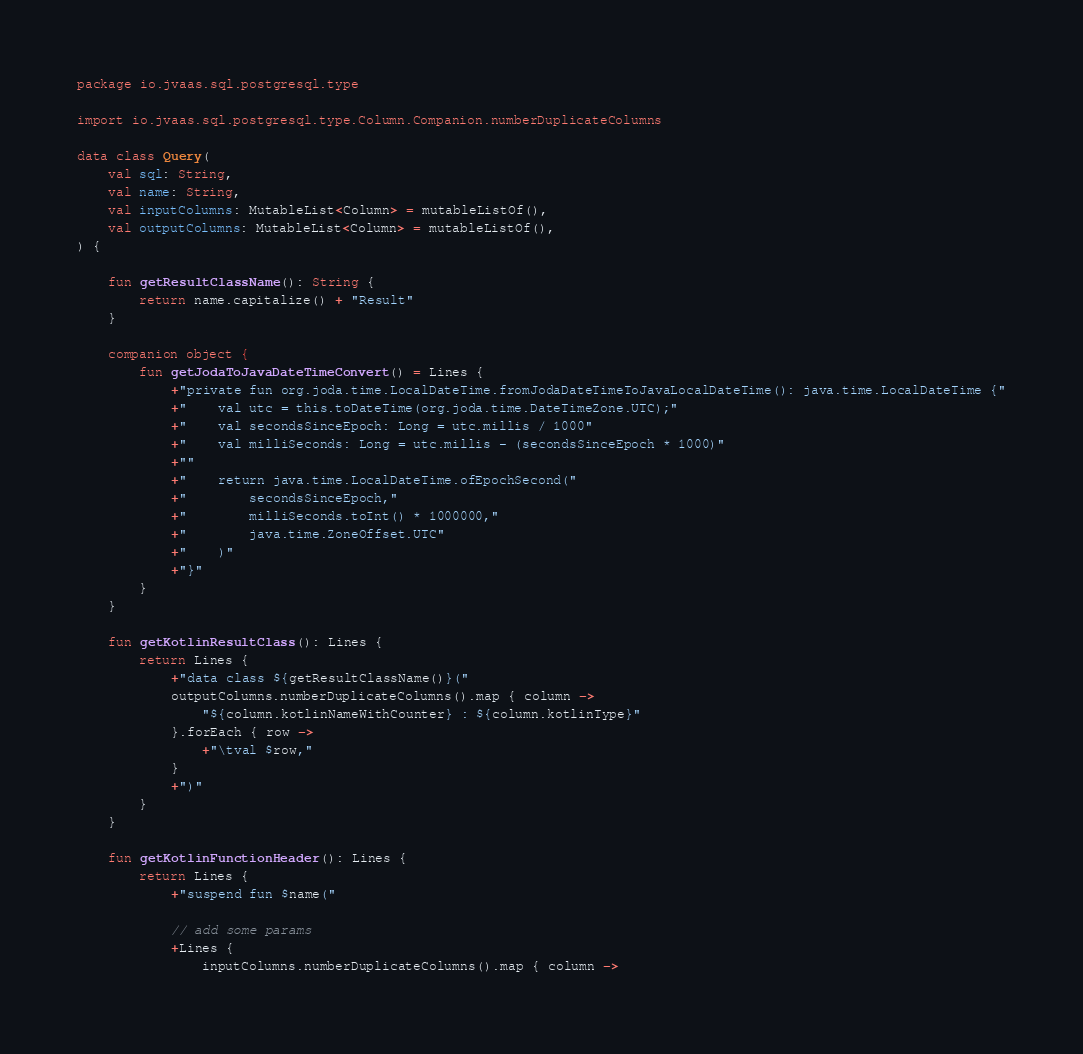Convert code to text. <code><loc_0><loc_0><loc_500><loc_500><_Kotlin_>package io.jvaas.sql.postgresql.type

import io.jvaas.sql.postgresql.type.Column.Companion.numberDuplicateColumns

data class Query(
	val sql: String,
	val name: String,
	val inputColumns: MutableList<Column> = mutableListOf(),
	val outputColumns: MutableList<Column> = mutableListOf(),
) {

	fun getResultClassName(): String {
		return name.capitalize() + "Result"
	}

	companion object {
		fun getJodaToJavaDateTimeConvert() = Lines {
			+"private fun org.joda.time.LocalDateTime.fromJodaDateTimeToJavaLocalDateTime(): java.time.LocalDateTime {"
			+"	val utc = this.toDateTime(org.joda.time.DateTimeZone.UTC);"
			+"	val secondsSinceEpoch: Long = utc.millis / 1000"
			+"	val milliSeconds: Long = utc.millis - (secondsSinceEpoch * 1000)"
			+""
			+"	return java.time.LocalDateTime.ofEpochSecond("
			+"		secondsSinceEpoch,"
			+"		milliSeconds.toInt() * 1000000,"
			+"		java.time.ZoneOffset.UTC"
			+"	)"
			+"}"
		}
	}

	fun getKotlinResultClass(): Lines {
		return Lines {
			+"data class ${getResultClassName()}("
			outputColumns.numberDuplicateColumns().map { column ->
				"${column.kotlinNameWithCounter} : ${column.kotlinType}"
			}.forEach { row ->
				+"\tval $row,"
			}
			+")"
		}
	}

	fun getKotlinFunctionHeader(): Lines {
		return Lines {
			+"suspend fun $name("

			// add some params
			+Lines {
				inputColumns.numberDuplicateColumns().map { column -></code> 